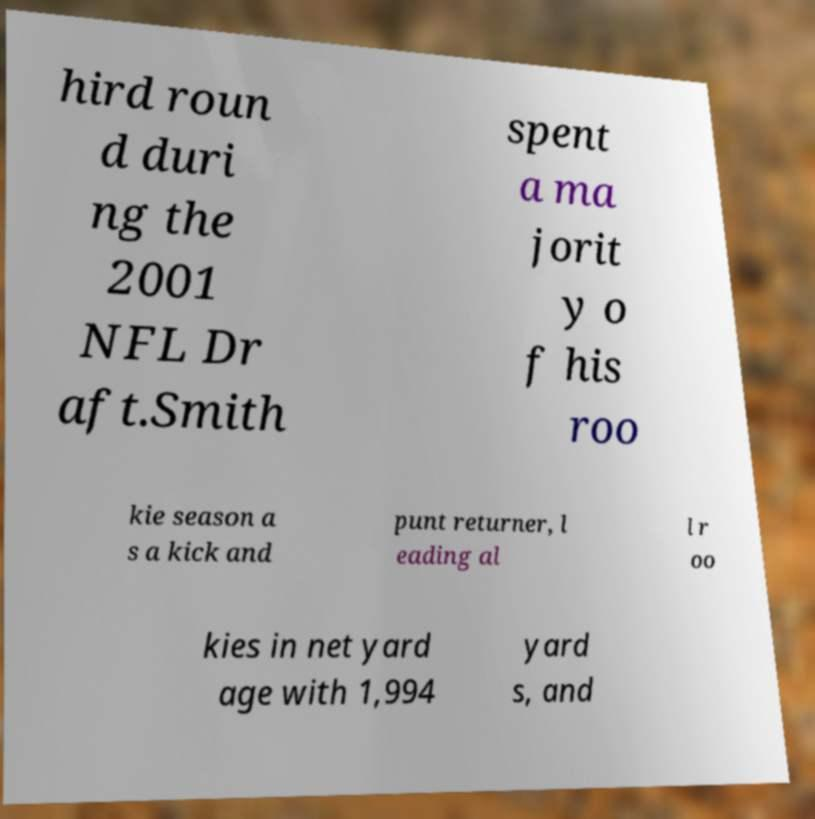There's text embedded in this image that I need extracted. Can you transcribe it verbatim? hird roun d duri ng the 2001 NFL Dr aft.Smith spent a ma jorit y o f his roo kie season a s a kick and punt returner, l eading al l r oo kies in net yard age with 1,994 yard s, and 